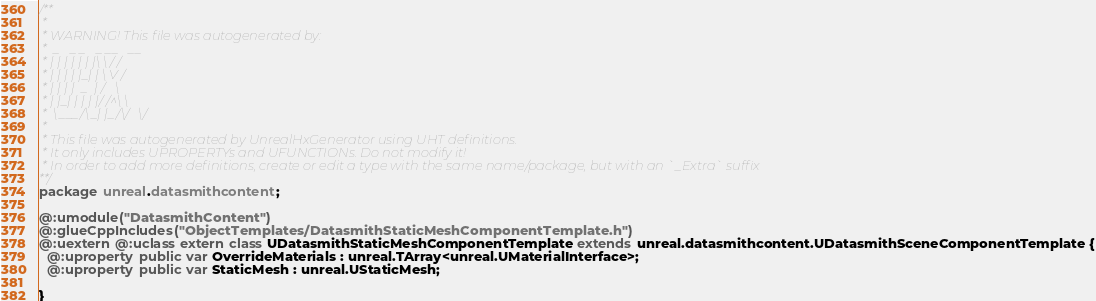Convert code to text. <code><loc_0><loc_0><loc_500><loc_500><_Haxe_>/**
 * 
 * WARNING! This file was autogenerated by: 
 *  _   _ _   _ __   __ 
 * | | | | | | |\ \ / / 
 * | | | | |_| | \ V /  
 * | | | |  _  | /   \  
 * | |_| | | | |/ /^\ \ 
 *  \___/\_| |_/\/   \/ 
 * 
 * This file was autogenerated by UnrealHxGenerator using UHT definitions.
 * It only includes UPROPERTYs and UFUNCTIONs. Do not modify it!
 * In order to add more definitions, create or edit a type with the same name/package, but with an `_Extra` suffix
**/
package unreal.datasmithcontent;

@:umodule("DatasmithContent")
@:glueCppIncludes("ObjectTemplates/DatasmithStaticMeshComponentTemplate.h")
@:uextern @:uclass extern class UDatasmithStaticMeshComponentTemplate extends unreal.datasmithcontent.UDatasmithSceneComponentTemplate {
  @:uproperty public var OverrideMaterials : unreal.TArray<unreal.UMaterialInterface>;
  @:uproperty public var StaticMesh : unreal.UStaticMesh;
  
}
</code> 